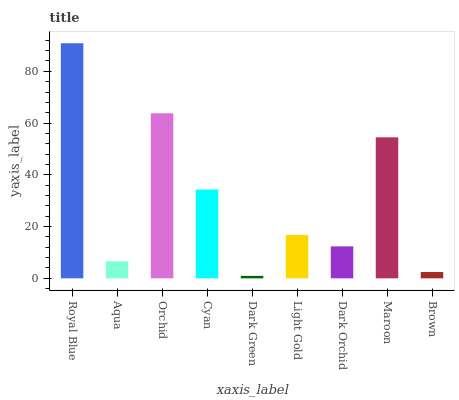Is Aqua the minimum?
Answer yes or no. No. Is Aqua the maximum?
Answer yes or no. No. Is Royal Blue greater than Aqua?
Answer yes or no. Yes. Is Aqua less than Royal Blue?
Answer yes or no. Yes. Is Aqua greater than Royal Blue?
Answer yes or no. No. Is Royal Blue less than Aqua?
Answer yes or no. No. Is Light Gold the high median?
Answer yes or no. Yes. Is Light Gold the low median?
Answer yes or no. Yes. Is Dark Orchid the high median?
Answer yes or no. No. Is Dark Green the low median?
Answer yes or no. No. 